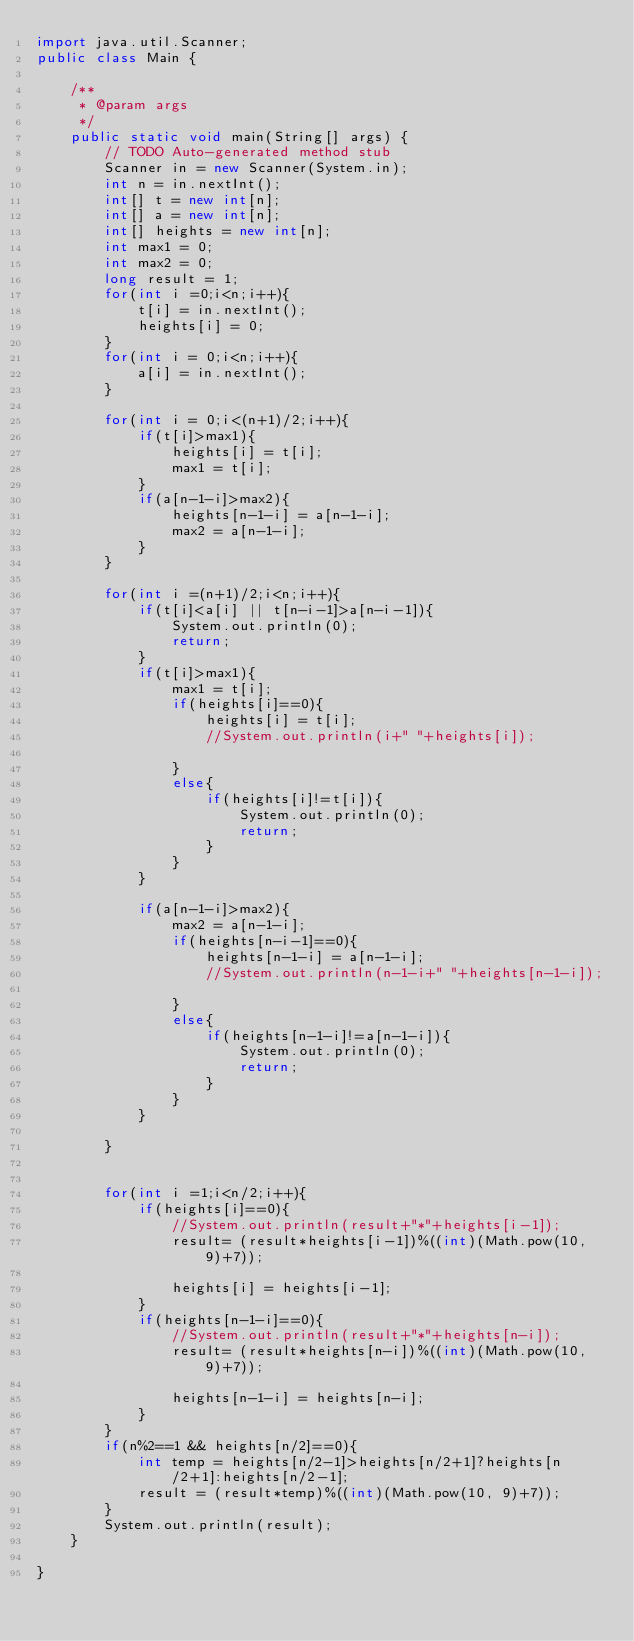Convert code to text. <code><loc_0><loc_0><loc_500><loc_500><_Java_>import java.util.Scanner;
public class Main {

	/**
	 * @param args
	 */
	public static void main(String[] args) {
		// TODO Auto-generated method stub
		Scanner in = new Scanner(System.in);
		int n = in.nextInt();
		int[] t = new int[n];
		int[] a = new int[n];	
		int[] heights = new int[n];
		int max1 = 0;
		int max2 = 0;
		long result = 1;
		for(int i =0;i<n;i++){
			t[i] = in.nextInt();
			heights[i] = 0;
		}
		for(int i = 0;i<n;i++){
			a[i] = in.nextInt();
		}

		for(int i = 0;i<(n+1)/2;i++){
			if(t[i]>max1){
				heights[i] = t[i];
				max1 = t[i];
			}
			if(a[n-1-i]>max2){
				heights[n-1-i] = a[n-1-i];
				max2 = a[n-1-i];
			}
		}		

		for(int i =(n+1)/2;i<n;i++){
			if(t[i]<a[i] || t[n-i-1]>a[n-i-1]){
				System.out.println(0);
				return;
			}
			if(t[i]>max1){	
				max1 = t[i];
				if(heights[i]==0){
					heights[i] = t[i];
					//System.out.println(i+" "+heights[i]);

				}
				else{
					if(heights[i]!=t[i]){
						System.out.println(0);
						return;
					}
				}			
			}

			if(a[n-1-i]>max2){
				max2 = a[n-1-i];
				if(heights[n-i-1]==0){
					heights[n-1-i] = a[n-1-i];
					//System.out.println(n-1-i+" "+heights[n-1-i]);

				}
				else{
					if(heights[n-1-i]!=a[n-1-i]){
						System.out.println(0);
						return;
					}
				}			
			}

		}


		for(int i =1;i<n/2;i++){
			if(heights[i]==0){
				//System.out.println(result+"*"+heights[i-1]);
				result= (result*heights[i-1])%((int)(Math.pow(10, 9)+7));
				
				heights[i] = heights[i-1];
			}
			if(heights[n-1-i]==0){
				//System.out.println(result+"*"+heights[n-i]);
				result= (result*heights[n-i])%((int)(Math.pow(10, 9)+7));
				
				heights[n-1-i] = heights[n-i];
			}
		}
		if(n%2==1 && heights[n/2]==0){
			int temp = heights[n/2-1]>heights[n/2+1]?heights[n/2+1]:heights[n/2-1];
			result = (result*temp)%((int)(Math.pow(10, 9)+7));
		}
		System.out.println(result);
	}

}
</code> 